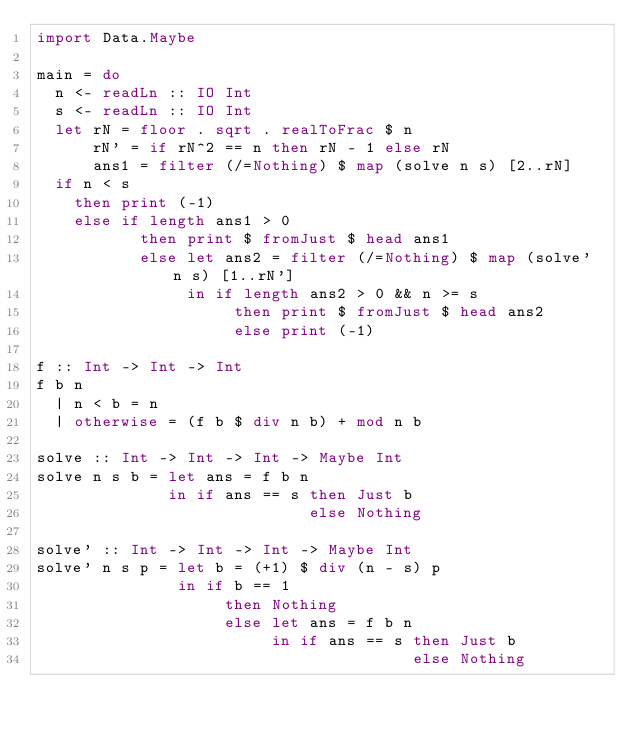Convert code to text. <code><loc_0><loc_0><loc_500><loc_500><_Haskell_>import Data.Maybe

main = do
  n <- readLn :: IO Int
  s <- readLn :: IO Int
  let rN = floor . sqrt . realToFrac $ n
      rN' = if rN^2 == n then rN - 1 else rN
      ans1 = filter (/=Nothing) $ map (solve n s) [2..rN]
  if n < s
    then print (-1)
    else if length ans1 > 0
           then print $ fromJust $ head ans1
           else let ans2 = filter (/=Nothing) $ map (solve' n s) [1..rN']
                in if length ans2 > 0 && n >= s
                     then print $ fromJust $ head ans2
                     else print (-1)

f :: Int -> Int -> Int
f b n
  | n < b = n
  | otherwise = (f b $ div n b) + mod n b

solve :: Int -> Int -> Int -> Maybe Int
solve n s b = let ans = f b n
              in if ans == s then Just b
                             else Nothing

solve' :: Int -> Int -> Int -> Maybe Int
solve' n s p = let b = (+1) $ div (n - s) p
               in if b == 1
                    then Nothing
                    else let ans = f b n
                         in if ans == s then Just b
                                        else Nothing
</code> 